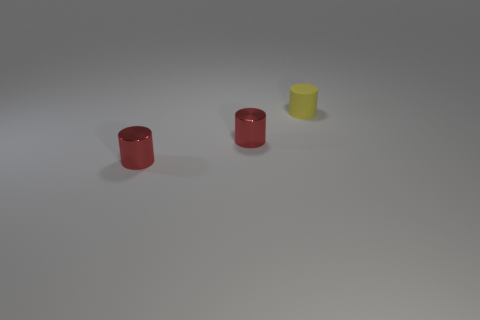What number of balls are either small matte objects or red shiny objects? The question seems to be based on a misunderstanding as there are no balls in the image. Instead, there are three cylindrical objects; two are shiny and red, and one is matte and yellow. So, there are two red shiny objects and no small matte balls. 